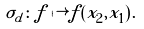Convert formula to latex. <formula><loc_0><loc_0><loc_500><loc_500>\sigma _ { d } \colon f \mapsto f ( x _ { 2 } , x _ { 1 } ) \text {.}</formula> 